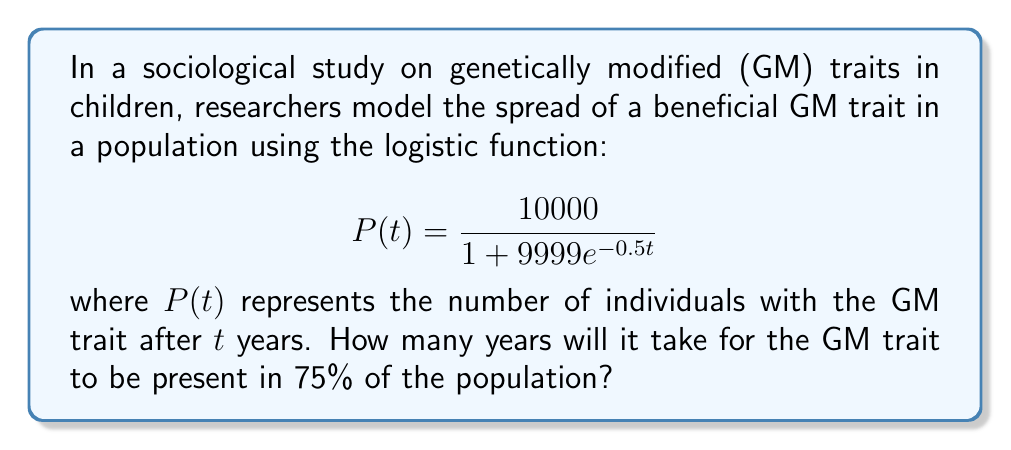Provide a solution to this math problem. To solve this problem, we need to follow these steps:

1) The total population is 10,000 (the carrying capacity of the logistic function).

2) We want to find when 75% of the population has the GM trait, which is:
   $0.75 \times 10000 = 7500$ individuals

3) Set up the equation:
   $$7500 = \frac{10000}{1 + 9999e^{-0.5t}}$$

4) Multiply both sides by the denominator:
   $$7500(1 + 9999e^{-0.5t}) = 10000$$

5) Distribute on the left side:
   $$7500 + 74992500e^{-0.5t} = 10000$$

6) Subtract 7500 from both sides:
   $$74992500e^{-0.5t} = 2500$$

7) Divide both sides by 74992500:
   $$e^{-0.5t} = \frac{1}{29997}$$

8) Take the natural log of both sides:
   $$-0.5t = \ln(\frac{1}{29997}) = -\ln(29997)$$

9) Divide both sides by -0.5:
   $$t = \frac{\ln(29997)}{0.5} \approx 20.61$$

10) Since we're dealing with years, we round up to the nearest whole year.
Answer: 21 years 